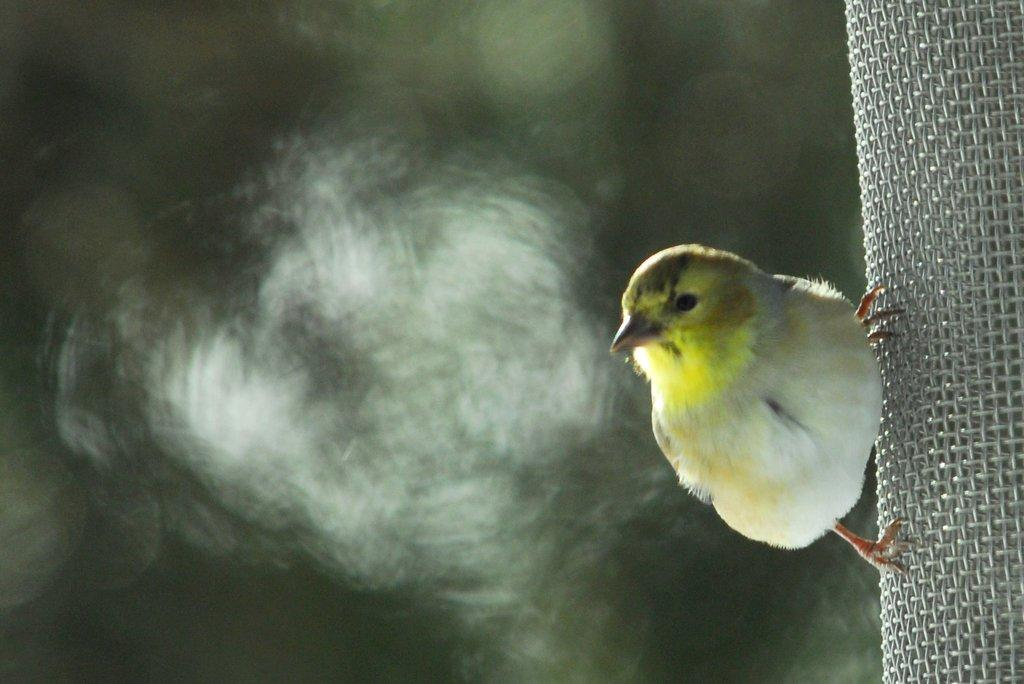What type of animal can be seen on the mesh in the image? There is a bird on the mesh on the right side of the image. Can you describe the background of the image? The background of the image is blurred. What type of apparel is the bird wearing in the image? There is no apparel present on the bird in the image, as birds do not wear clothing. 